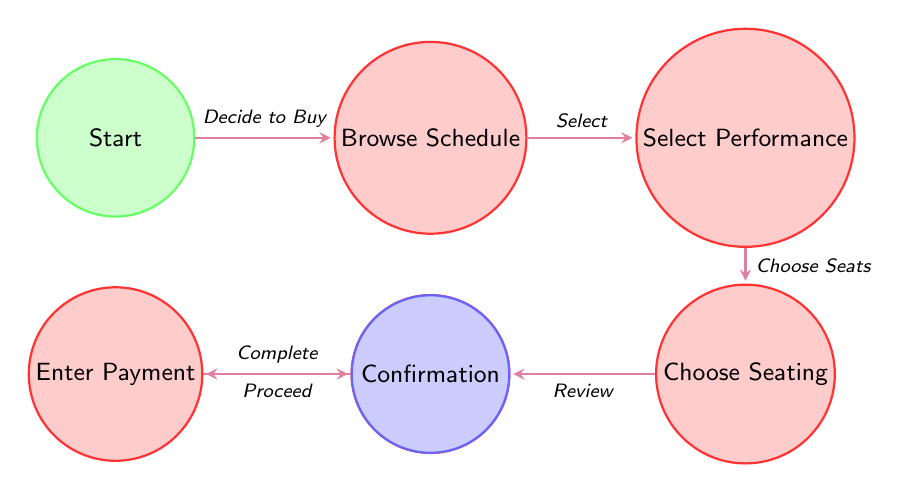What is the initial state of the finite state machine? The initial state is labeled as "Start," which represents the beginning of the ticket-buying process for the Mariinsky Theatre.
Answer: Start How many states are present in the diagram? By counting the unique states in the diagram, we find that there are a total of seven states involved in the ticket purchase process.
Answer: Seven What action leads from "Browse Performance Schedule" to "Select Performance"? The action that leads from "Browse Performance Schedule" to "Select Performance" is "Select a Performance," indicating the user's choice after reviewing the schedule.
Answer: Select a Performance What is the final state of the finite state machine? The final state, which represents the end of the process where the user is informed about their ticket purchase, is labeled as "Confirmation."
Answer: Confirmation Which state follows "Enter Payment Details"? The state that follows "Enter Payment Details" is "Confirmation," indicating the completion of the ticket buying process after payment has been made.
Answer: Confirmation What action transitions from "Review Order" to "Enter Payment Details"? The transition from "Review Order" to "Enter Payment Details" occurs through the action "Proceed to Payment," which indicates the user's decision to finalize the purchase.
Answer: Proceed to Payment What state do you enter after choosing a performance? After choosing a performance, the next state is "Choose Seating," where the user selects their preferred seating options based on availability.
Answer: Choose Seating What is the direct connection between "Choose Seating" and "Review Order"? The direct connection between "Choose Seating" and "Review Order" involves the action of "Review Selected Options," which leads the user to confirm their seating choices before proceeding.
Answer: Review Selected Options What action is taken from "Select Performance" to "Choose Seating"? The action taken to transition from "Select Performance" to "Choose Seating" is "Choose Seating Option," representing the user's choice of specific seating after selecting a performance.
Answer: Choose Seating Option 